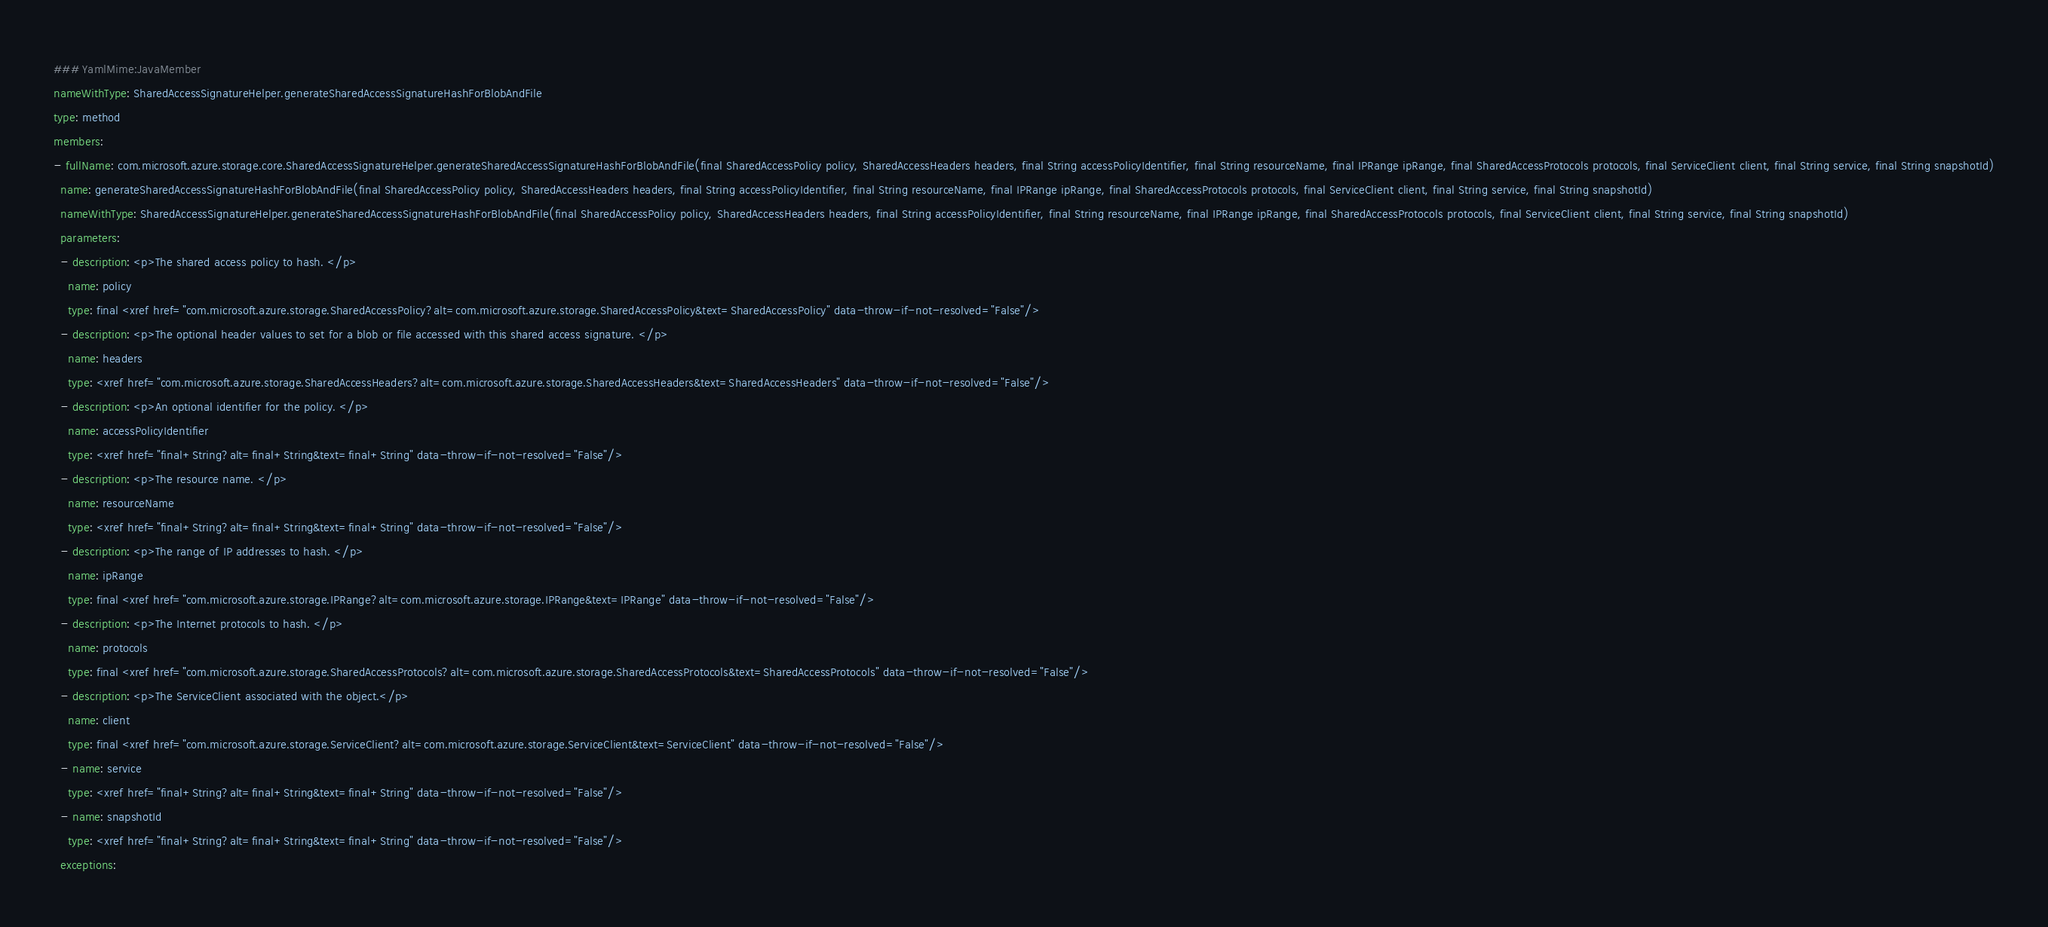Convert code to text. <code><loc_0><loc_0><loc_500><loc_500><_YAML_>### YamlMime:JavaMember
nameWithType: SharedAccessSignatureHelper.generateSharedAccessSignatureHashForBlobAndFile
type: method
members:
- fullName: com.microsoft.azure.storage.core.SharedAccessSignatureHelper.generateSharedAccessSignatureHashForBlobAndFile(final SharedAccessPolicy policy, SharedAccessHeaders headers, final String accessPolicyIdentifier, final String resourceName, final IPRange ipRange, final SharedAccessProtocols protocols, final ServiceClient client, final String service, final String snapshotId)
  name: generateSharedAccessSignatureHashForBlobAndFile(final SharedAccessPolicy policy, SharedAccessHeaders headers, final String accessPolicyIdentifier, final String resourceName, final IPRange ipRange, final SharedAccessProtocols protocols, final ServiceClient client, final String service, final String snapshotId)
  nameWithType: SharedAccessSignatureHelper.generateSharedAccessSignatureHashForBlobAndFile(final SharedAccessPolicy policy, SharedAccessHeaders headers, final String accessPolicyIdentifier, final String resourceName, final IPRange ipRange, final SharedAccessProtocols protocols, final ServiceClient client, final String service, final String snapshotId)
  parameters:
  - description: <p>The shared access policy to hash. </p>
    name: policy
    type: final <xref href="com.microsoft.azure.storage.SharedAccessPolicy?alt=com.microsoft.azure.storage.SharedAccessPolicy&text=SharedAccessPolicy" data-throw-if-not-resolved="False"/>
  - description: <p>The optional header values to set for a blob or file accessed with this shared access signature. </p>
    name: headers
    type: <xref href="com.microsoft.azure.storage.SharedAccessHeaders?alt=com.microsoft.azure.storage.SharedAccessHeaders&text=SharedAccessHeaders" data-throw-if-not-resolved="False"/>
  - description: <p>An optional identifier for the policy. </p>
    name: accessPolicyIdentifier
    type: <xref href="final+String?alt=final+String&text=final+String" data-throw-if-not-resolved="False"/>
  - description: <p>The resource name. </p>
    name: resourceName
    type: <xref href="final+String?alt=final+String&text=final+String" data-throw-if-not-resolved="False"/>
  - description: <p>The range of IP addresses to hash. </p>
    name: ipRange
    type: final <xref href="com.microsoft.azure.storage.IPRange?alt=com.microsoft.azure.storage.IPRange&text=IPRange" data-throw-if-not-resolved="False"/>
  - description: <p>The Internet protocols to hash. </p>
    name: protocols
    type: final <xref href="com.microsoft.azure.storage.SharedAccessProtocols?alt=com.microsoft.azure.storage.SharedAccessProtocols&text=SharedAccessProtocols" data-throw-if-not-resolved="False"/>
  - description: <p>The ServiceClient associated with the object.</p>
    name: client
    type: final <xref href="com.microsoft.azure.storage.ServiceClient?alt=com.microsoft.azure.storage.ServiceClient&text=ServiceClient" data-throw-if-not-resolved="False"/>
  - name: service
    type: <xref href="final+String?alt=final+String&text=final+String" data-throw-if-not-resolved="False"/>
  - name: snapshotId
    type: <xref href="final+String?alt=final+String&text=final+String" data-throw-if-not-resolved="False"/>
  exceptions:</code> 